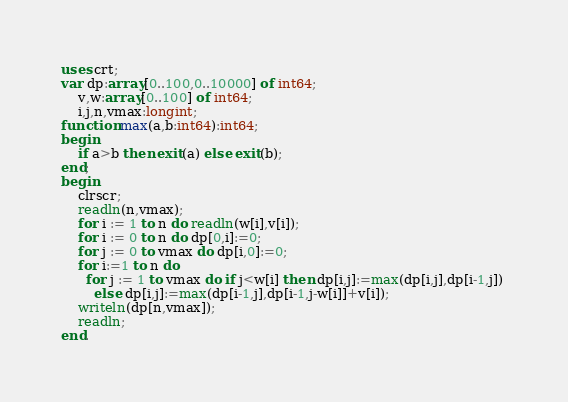Convert code to text. <code><loc_0><loc_0><loc_500><loc_500><_Pascal_>uses crt;
var dp:array[0..100,0..10000] of int64;
    v,w:array[0..100] of int64;
    i,j,n,vmax:longint;
function max(a,b:int64):int64;
begin
    if a>b then exit(a) else exit(b);
end;
begin
    clrscr;
    readln(n,vmax);
    for i := 1 to n do readln(w[i],v[i]);
    for i := 0 to n do dp[0,i]:=0;
    for j := 0 to vmax do dp[i,0]:=0;
    for i:=1 to n do 
      for j := 1 to vmax do if j<w[i] then dp[i,j]:=max(dp[i,j],dp[i-1,j]) 
        else dp[i,j]:=max(dp[i-1,j],dp[i-1,j-w[i]]+v[i]);
    writeln(dp[n,vmax]);
    readln;
end.</code> 